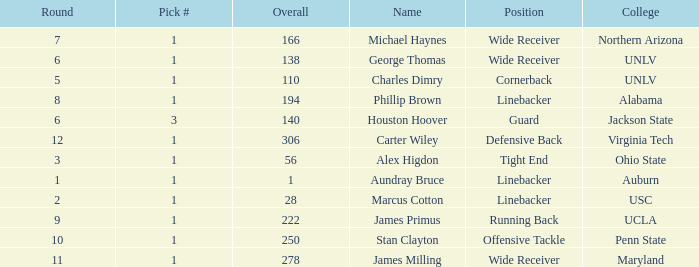What is Aundray Bruce's Pick #? 1.0. 